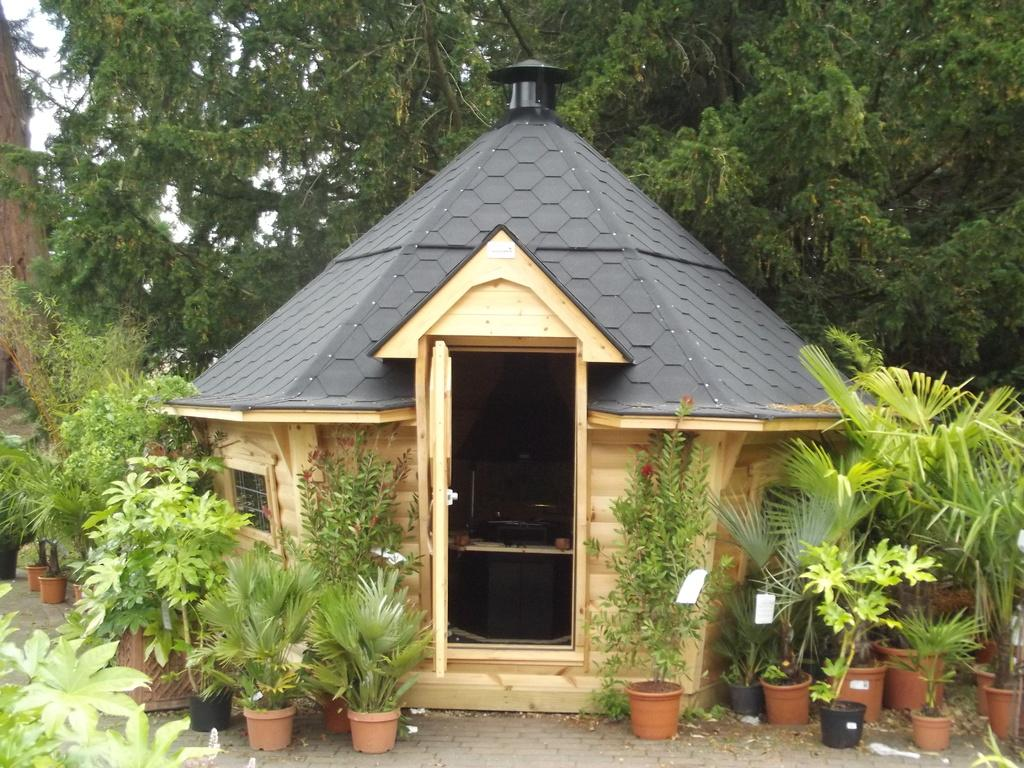What type of structure is in the image? There is a hut in the image. What is located in front of the hut? There are plants in pots in front of the hut. What is located behind the hut? There are trees behind the hut. What is visible in the image besides the hut and plants? The sky is visible in the image. Can you tell me how many giraffes are visible in the image? There are no giraffes present in the image. What type of verse is written on the hut in the image? There is no verse written on the hut in the image. 